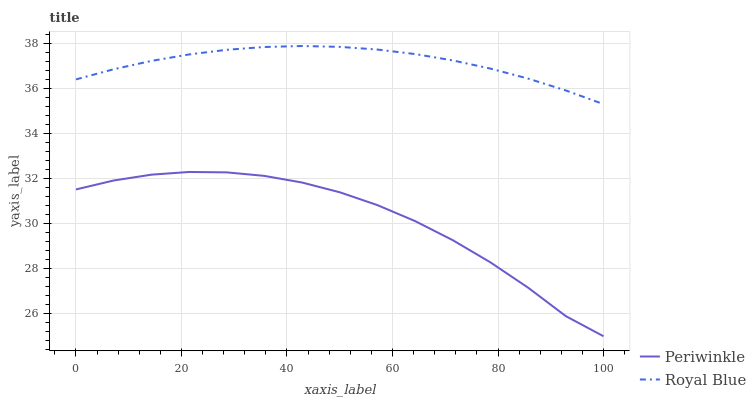Does Periwinkle have the minimum area under the curve?
Answer yes or no. Yes. Does Royal Blue have the maximum area under the curve?
Answer yes or no. Yes. Does Periwinkle have the maximum area under the curve?
Answer yes or no. No. Is Royal Blue the smoothest?
Answer yes or no. Yes. Is Periwinkle the roughest?
Answer yes or no. Yes. Is Periwinkle the smoothest?
Answer yes or no. No. Does Periwinkle have the lowest value?
Answer yes or no. Yes. Does Royal Blue have the highest value?
Answer yes or no. Yes. Does Periwinkle have the highest value?
Answer yes or no. No. Is Periwinkle less than Royal Blue?
Answer yes or no. Yes. Is Royal Blue greater than Periwinkle?
Answer yes or no. Yes. Does Periwinkle intersect Royal Blue?
Answer yes or no. No. 